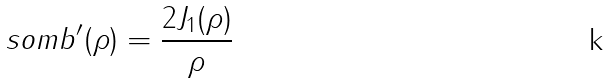<formula> <loc_0><loc_0><loc_500><loc_500>s o m b ^ { \prime } ( \rho ) = \frac { 2 J _ { 1 } ( \rho ) } { \rho }</formula> 